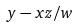<formula> <loc_0><loc_0><loc_500><loc_500>y - x z / w</formula> 